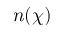Convert formula to latex. <formula><loc_0><loc_0><loc_500><loc_500>n ( \chi )</formula> 